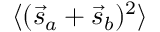Convert formula to latex. <formula><loc_0><loc_0><loc_500><loc_500>\langle ( { \vec { s } } _ { a } + { \vec { s } } _ { b } ) ^ { 2 } \rangle</formula> 